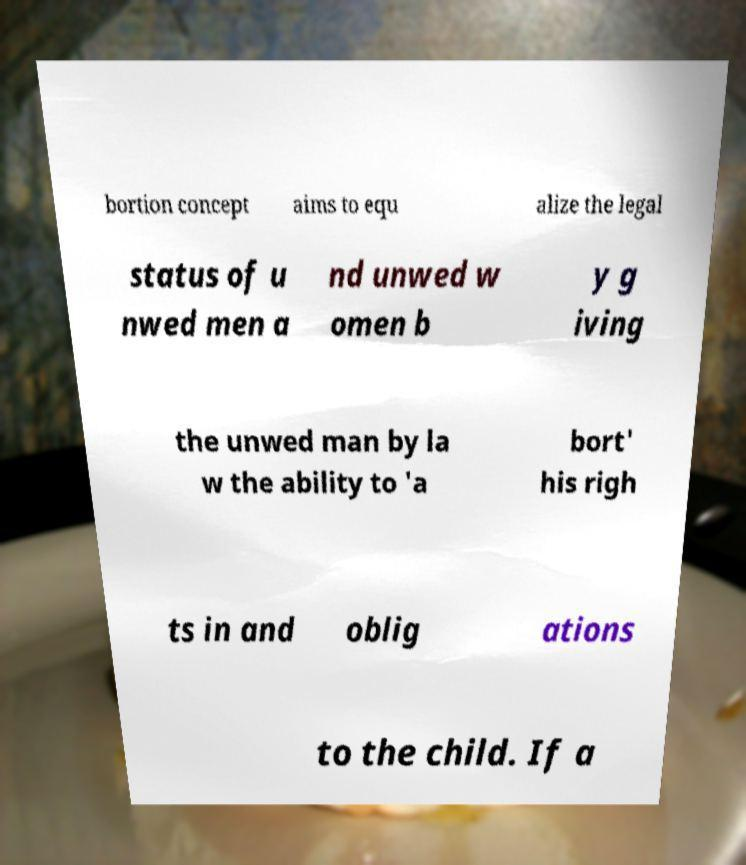For documentation purposes, I need the text within this image transcribed. Could you provide that? bortion concept aims to equ alize the legal status of u nwed men a nd unwed w omen b y g iving the unwed man by la w the ability to 'a bort' his righ ts in and oblig ations to the child. If a 